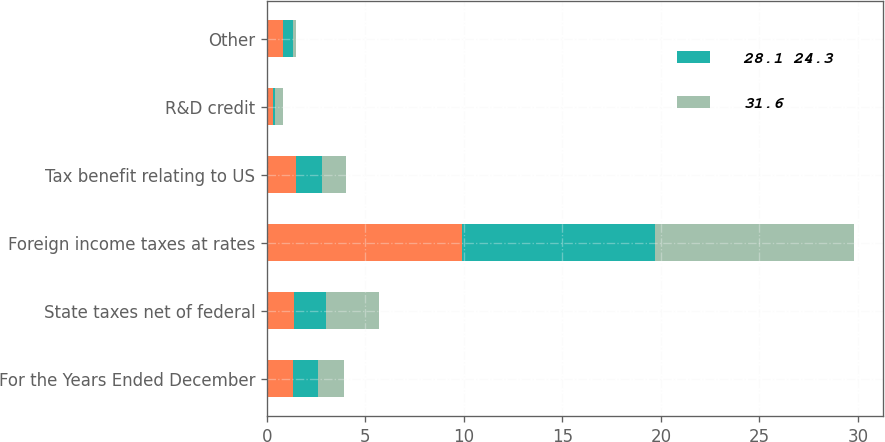Convert chart to OTSL. <chart><loc_0><loc_0><loc_500><loc_500><stacked_bar_chart><ecel><fcel>For the Years Ended December<fcel>State taxes net of federal<fcel>Foreign income taxes at rates<fcel>Tax benefit relating to US<fcel>R&D credit<fcel>Other<nl><fcel>nan<fcel>1.3<fcel>1.4<fcel>9.9<fcel>1.5<fcel>0.3<fcel>0.8<nl><fcel>28.1 24.3<fcel>1.3<fcel>1.6<fcel>9.8<fcel>1.3<fcel>0.1<fcel>0.5<nl><fcel>31.6<fcel>1.3<fcel>2.7<fcel>10.1<fcel>1.2<fcel>0.4<fcel>0.2<nl></chart> 